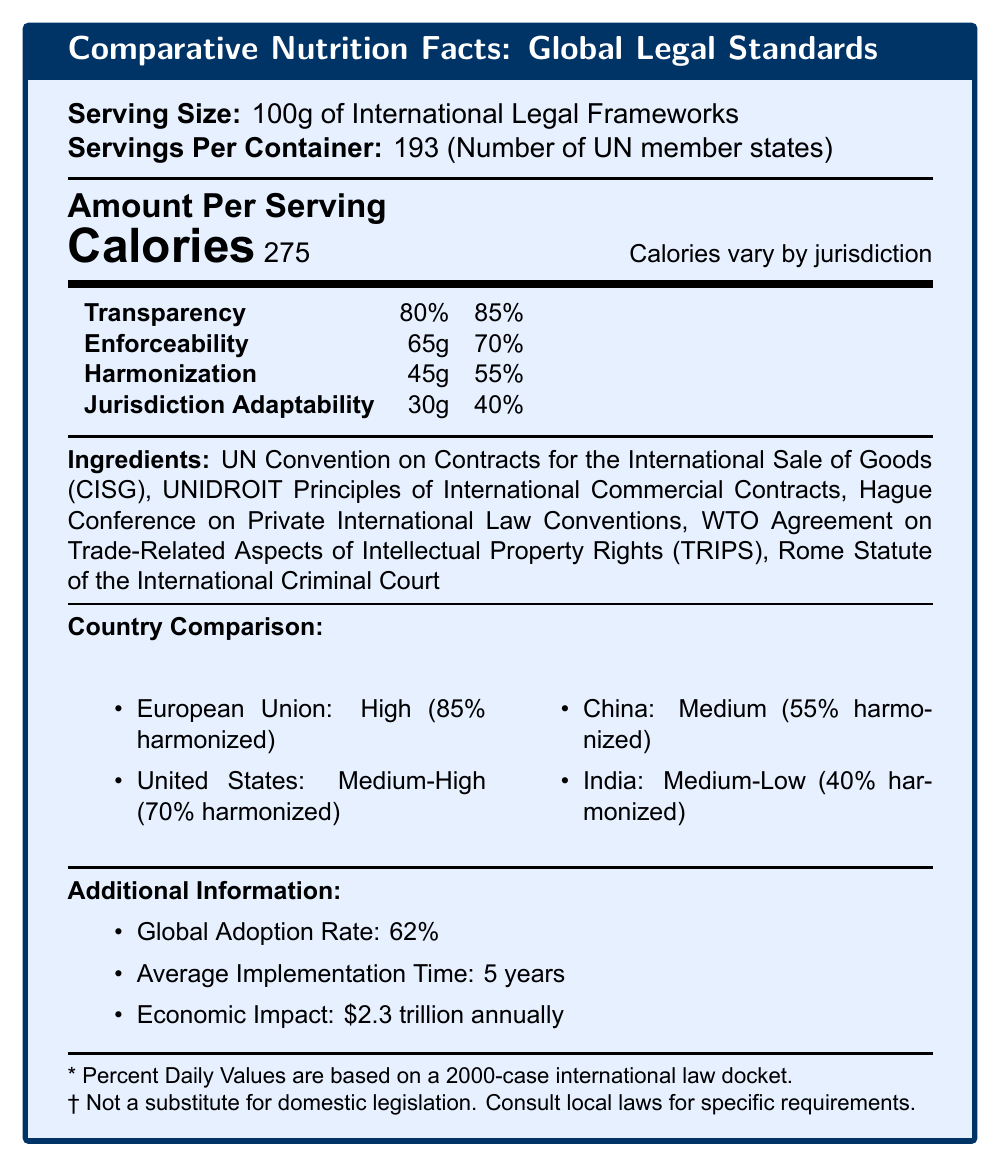what is the serving size? The document states, "Serving Size: 100g of International Legal Frameworks."
Answer: 100g of International Legal Frameworks how many UN member states are represented as servings per container? The document indicates, "Servings Per Container: 193 (Number of UN member states)."
Answer: 193 what is the global adoption rate of these legal standards? The section "Additional Information" mentions, "Global Adoption Rate: 62%."
Answer: 62% how many calories are per serving, and why might they vary? The document indicates "Calories: 275" and notes that "Calories vary by jurisdiction."
Answer: 275 calories what are some key ingredients listed in the document? The ingredients section lists these key international agreements and conventions.
Answer: UN Convention on Contracts for the International Sale of Goods (CISG), UNIDROIT Principles of International Commercial Contracts, Hague Conference on Private International Law Conventions, WTO TRIPS Agreement, Rome Statute of the International Criminal Court which country has the highest legal standard according to the document? A. United States B. European Union C. China D. India The country comparison section lists "European Union: High (85% harmonized)" as having the highest legal standard.
Answer: B. European Union what percentage of enforceability does the document state? A. 40% B. 55% C. 70% D. 85% The enforceability percentage in the daily values section is listed as 70%.
Answer: C. 70% how long is the average implementation time for these legal standards? The additional information section provides this as "Average Implementation Time: 5 years."
Answer: 5 years which country has the lowest percentage of harmonization? True/False: India has a legal standard classified as Medium. According to the country comparison section, India's legal standard is classified as Medium-Low, not Medium.
Answer: False summarize the document's main idea. The document serves as a concise comparison tool for understanding global legal standards' different aspects and their implementation rates and economic impacts.
Answer: The document "Comparative Nutrition Facts: Global Legal Standards" presents an overview of the harmonization and enforceability of international legal standards across various jurisdictions, highlighting key metrics such as transparency, enforceability, and adaptability. It also provides a comparison of legal standards in different countries and additional information on the global adoption rate and economic impact. how many grams of jurisdiction adaptability are there per serving? The daily values section lists 30g of "Jurisdiction Adaptability."
Answer: 30g what is the economic impact of the documented legal standards annually? The additional information section states, "Economic Impact: $2.3 trillion annually."
Answer: $2.3 trillion identify a disclaimer mentioned in the document. A. Only applicable to commercial contracts B. Based on a 2000-case international law docket C. Subject to change D. Not valid for trade laws One of the disclaimers states, "* Percent Daily Values are based on a 2000-case international law docket."
Answer: B. Based on a 2000-case international law docket which country is classified with a 'Medium-High' legal standard? The country comparison section lists "United States: Medium-High (70% harmonized)."
Answer: United States does the document mention specific dates for implementation? The document does not provide specific dates for implementation; it only mentions the average implementation time as 5 years.
Answer: Not enough information 